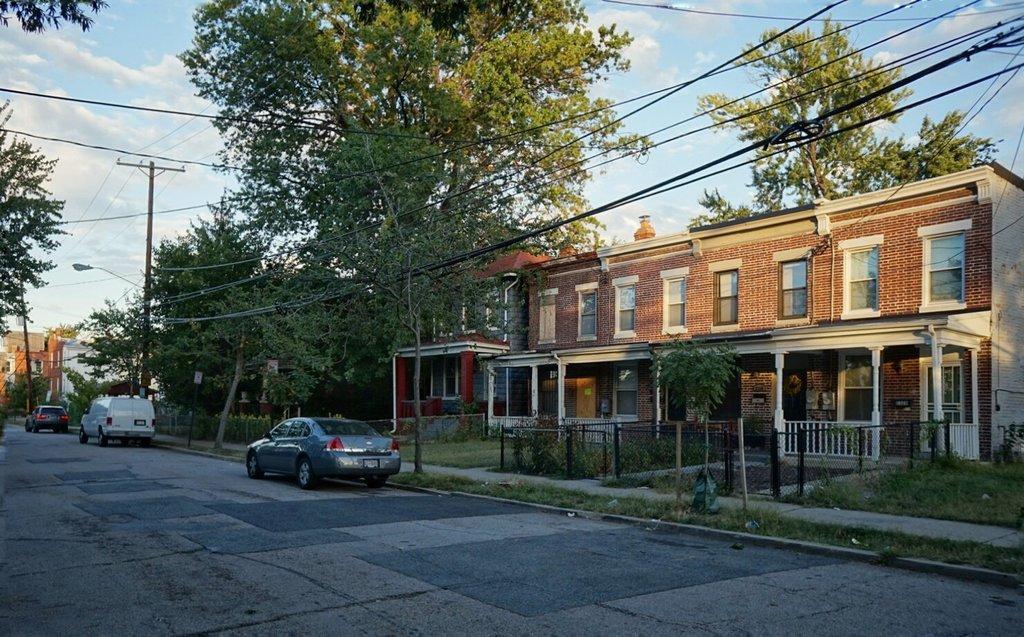In one or two sentences, can you explain what this image depicts? In the image we can see there are cars parked on the road, there are buildings and there are trees. There are electrical light pole wires. 